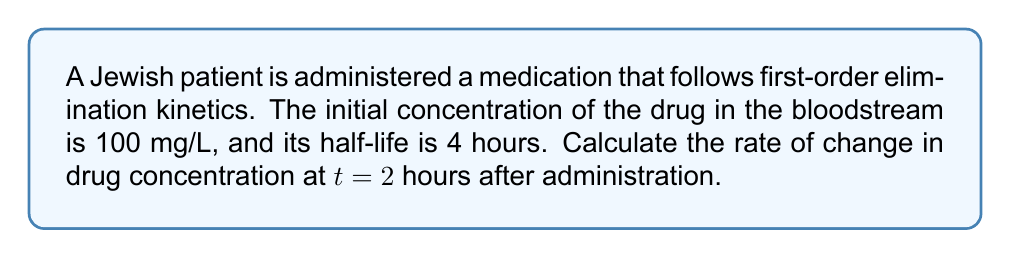Help me with this question. To solve this problem, we'll follow these steps:

1) First-order elimination kinetics follow the equation:
   $$C(t) = C_0 e^{-kt}$$
   where $C(t)$ is the concentration at time $t$, $C_0$ is the initial concentration, and $k$ is the elimination rate constant.

2) We need to find $k$ using the half-life ($t_{1/2}$):
   $$k = \frac{\ln(2)}{t_{1/2}} = \frac{\ln(2)}{4} = 0.1733 \text{ hr}^{-1}$$

3) The concentration function is:
   $$C(t) = 100e^{-0.1733t}$$

4) To find the rate of change, we need to differentiate $C(t)$ with respect to $t$:
   $$\frac{dC}{dt} = -0.1733 \cdot 100e^{-0.1733t} = -17.33e^{-0.1733t}$$

5) At $t = 2$ hours:
   $$\frac{dC}{dt}\bigg|_{t=2} = -17.33e^{-0.1733 \cdot 2} = -17.33e^{-0.3466} = -11.89 \text{ mg/L/hr}$$

The negative sign indicates that the concentration is decreasing over time.
Answer: $-11.89 \text{ mg/L/hr}$ 